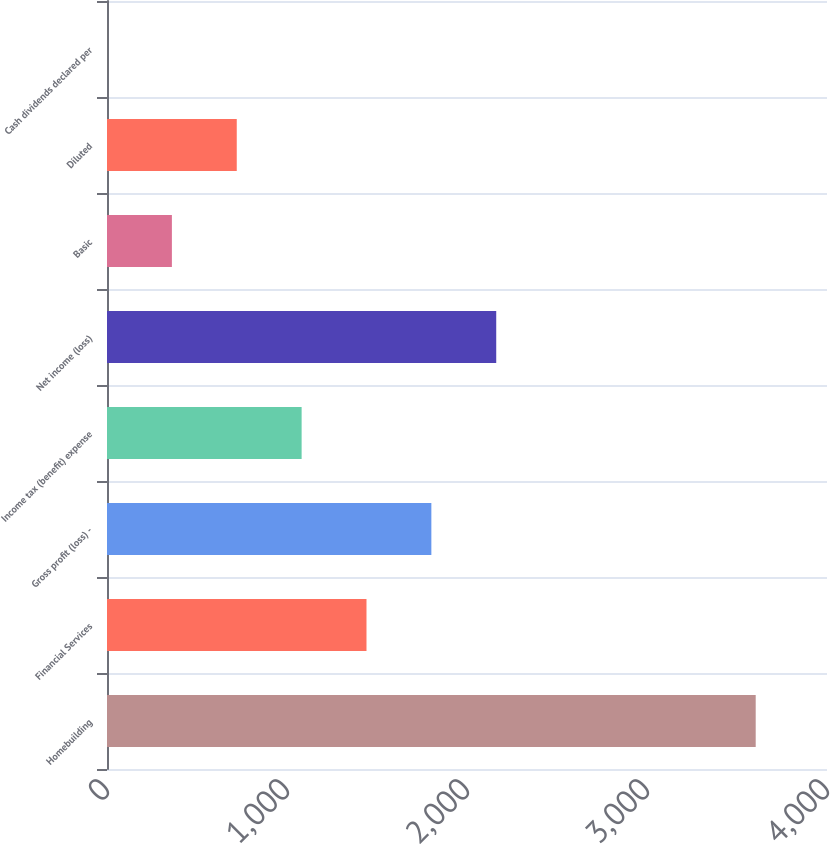Convert chart to OTSL. <chart><loc_0><loc_0><loc_500><loc_500><bar_chart><fcel>Homebuilding<fcel>Financial Services<fcel>Gross profit (loss) -<fcel>Income tax (benefit) expense<fcel>Net income (loss)<fcel>Basic<fcel>Diluted<fcel>Cash dividends declared per<nl><fcel>3603.9<fcel>1441.63<fcel>1802.01<fcel>1081.26<fcel>2162.39<fcel>360.52<fcel>720.89<fcel>0.15<nl></chart> 